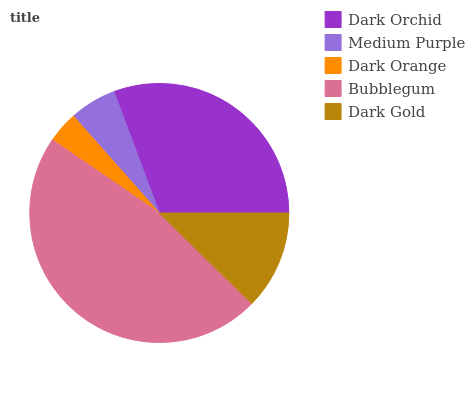Is Dark Orange the minimum?
Answer yes or no. Yes. Is Bubblegum the maximum?
Answer yes or no. Yes. Is Medium Purple the minimum?
Answer yes or no. No. Is Medium Purple the maximum?
Answer yes or no. No. Is Dark Orchid greater than Medium Purple?
Answer yes or no. Yes. Is Medium Purple less than Dark Orchid?
Answer yes or no. Yes. Is Medium Purple greater than Dark Orchid?
Answer yes or no. No. Is Dark Orchid less than Medium Purple?
Answer yes or no. No. Is Dark Gold the high median?
Answer yes or no. Yes. Is Dark Gold the low median?
Answer yes or no. Yes. Is Dark Orchid the high median?
Answer yes or no. No. Is Dark Orchid the low median?
Answer yes or no. No. 